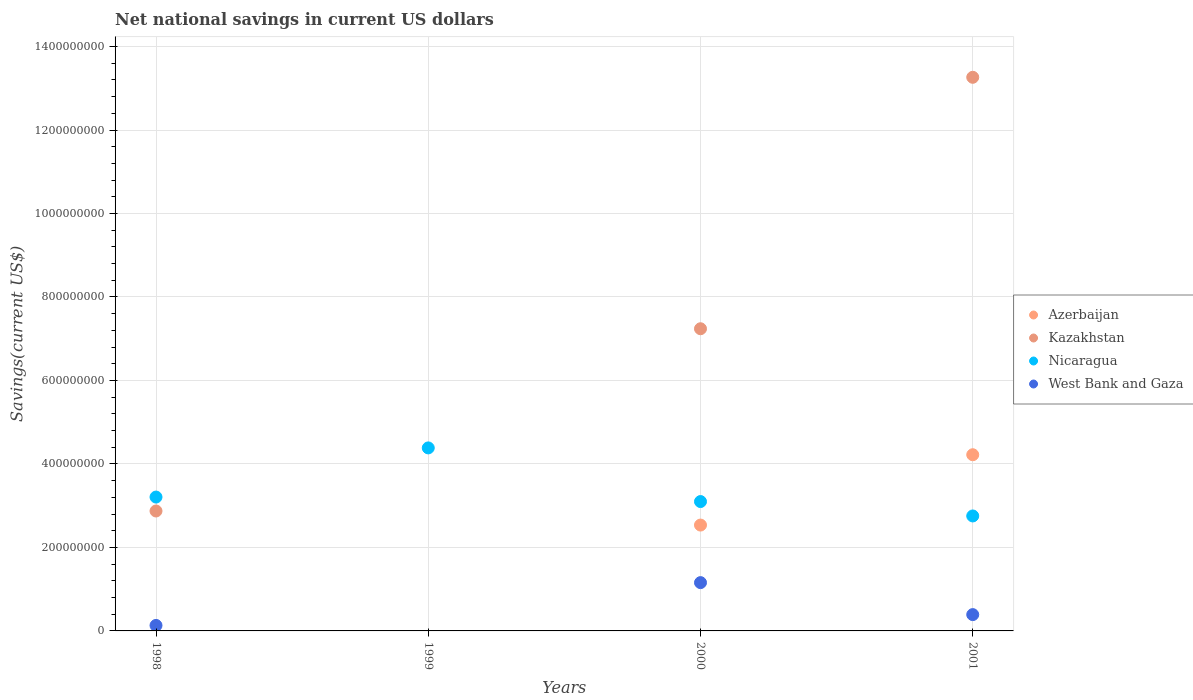How many different coloured dotlines are there?
Your response must be concise. 4. Is the number of dotlines equal to the number of legend labels?
Offer a very short reply. No. What is the net national savings in Nicaragua in 1998?
Give a very brief answer. 3.21e+08. Across all years, what is the maximum net national savings in Nicaragua?
Give a very brief answer. 4.38e+08. Across all years, what is the minimum net national savings in Azerbaijan?
Your response must be concise. 0. What is the total net national savings in Kazakhstan in the graph?
Ensure brevity in your answer.  2.34e+09. What is the difference between the net national savings in Nicaragua in 1998 and that in 2000?
Your answer should be very brief. 1.08e+07. What is the difference between the net national savings in Kazakhstan in 1998 and the net national savings in Nicaragua in 2001?
Ensure brevity in your answer.  1.19e+07. What is the average net national savings in Kazakhstan per year?
Your answer should be compact. 5.84e+08. In the year 2000, what is the difference between the net national savings in Kazakhstan and net national savings in West Bank and Gaza?
Offer a very short reply. 6.08e+08. What is the ratio of the net national savings in Nicaragua in 1999 to that in 2001?
Make the answer very short. 1.59. Is the difference between the net national savings in Kazakhstan in 1998 and 2001 greater than the difference between the net national savings in West Bank and Gaza in 1998 and 2001?
Offer a very short reply. No. What is the difference between the highest and the second highest net national savings in West Bank and Gaza?
Provide a short and direct response. 7.66e+07. What is the difference between the highest and the lowest net national savings in Azerbaijan?
Give a very brief answer. 4.22e+08. In how many years, is the net national savings in Kazakhstan greater than the average net national savings in Kazakhstan taken over all years?
Your answer should be compact. 2. Is the sum of the net national savings in Kazakhstan in 1998 and 2000 greater than the maximum net national savings in Nicaragua across all years?
Ensure brevity in your answer.  Yes. Does the net national savings in Kazakhstan monotonically increase over the years?
Your answer should be very brief. No. Is the net national savings in Azerbaijan strictly less than the net national savings in Kazakhstan over the years?
Your response must be concise. No. How many dotlines are there?
Your answer should be compact. 4. How many years are there in the graph?
Your response must be concise. 4. Does the graph contain any zero values?
Your response must be concise. Yes. Does the graph contain grids?
Ensure brevity in your answer.  Yes. Where does the legend appear in the graph?
Provide a succinct answer. Center right. What is the title of the graph?
Keep it short and to the point. Net national savings in current US dollars. Does "Guyana" appear as one of the legend labels in the graph?
Give a very brief answer. No. What is the label or title of the Y-axis?
Offer a terse response. Savings(current US$). What is the Savings(current US$) of Azerbaijan in 1998?
Offer a terse response. 0. What is the Savings(current US$) in Kazakhstan in 1998?
Offer a very short reply. 2.87e+08. What is the Savings(current US$) in Nicaragua in 1998?
Provide a succinct answer. 3.21e+08. What is the Savings(current US$) in West Bank and Gaza in 1998?
Your answer should be compact. 1.32e+07. What is the Savings(current US$) of Azerbaijan in 1999?
Make the answer very short. 0. What is the Savings(current US$) of Kazakhstan in 1999?
Your answer should be compact. 0. What is the Savings(current US$) in Nicaragua in 1999?
Provide a succinct answer. 4.38e+08. What is the Savings(current US$) of Azerbaijan in 2000?
Keep it short and to the point. 2.54e+08. What is the Savings(current US$) in Kazakhstan in 2000?
Offer a very short reply. 7.24e+08. What is the Savings(current US$) in Nicaragua in 2000?
Ensure brevity in your answer.  3.10e+08. What is the Savings(current US$) of West Bank and Gaza in 2000?
Your response must be concise. 1.16e+08. What is the Savings(current US$) of Azerbaijan in 2001?
Ensure brevity in your answer.  4.22e+08. What is the Savings(current US$) in Kazakhstan in 2001?
Ensure brevity in your answer.  1.33e+09. What is the Savings(current US$) of Nicaragua in 2001?
Provide a short and direct response. 2.75e+08. What is the Savings(current US$) of West Bank and Gaza in 2001?
Make the answer very short. 3.91e+07. Across all years, what is the maximum Savings(current US$) of Azerbaijan?
Your response must be concise. 4.22e+08. Across all years, what is the maximum Savings(current US$) in Kazakhstan?
Give a very brief answer. 1.33e+09. Across all years, what is the maximum Savings(current US$) in Nicaragua?
Offer a terse response. 4.38e+08. Across all years, what is the maximum Savings(current US$) of West Bank and Gaza?
Keep it short and to the point. 1.16e+08. Across all years, what is the minimum Savings(current US$) of Azerbaijan?
Provide a succinct answer. 0. Across all years, what is the minimum Savings(current US$) in Kazakhstan?
Provide a short and direct response. 0. Across all years, what is the minimum Savings(current US$) of Nicaragua?
Offer a terse response. 2.75e+08. Across all years, what is the minimum Savings(current US$) of West Bank and Gaza?
Offer a terse response. 0. What is the total Savings(current US$) of Azerbaijan in the graph?
Your response must be concise. 6.76e+08. What is the total Savings(current US$) of Kazakhstan in the graph?
Offer a very short reply. 2.34e+09. What is the total Savings(current US$) in Nicaragua in the graph?
Your answer should be very brief. 1.34e+09. What is the total Savings(current US$) of West Bank and Gaza in the graph?
Provide a succinct answer. 1.68e+08. What is the difference between the Savings(current US$) of Nicaragua in 1998 and that in 1999?
Keep it short and to the point. -1.18e+08. What is the difference between the Savings(current US$) in Kazakhstan in 1998 and that in 2000?
Offer a very short reply. -4.37e+08. What is the difference between the Savings(current US$) in Nicaragua in 1998 and that in 2000?
Ensure brevity in your answer.  1.08e+07. What is the difference between the Savings(current US$) of West Bank and Gaza in 1998 and that in 2000?
Provide a short and direct response. -1.03e+08. What is the difference between the Savings(current US$) in Kazakhstan in 1998 and that in 2001?
Make the answer very short. -1.04e+09. What is the difference between the Savings(current US$) in Nicaragua in 1998 and that in 2001?
Give a very brief answer. 4.52e+07. What is the difference between the Savings(current US$) in West Bank and Gaza in 1998 and that in 2001?
Offer a very short reply. -2.59e+07. What is the difference between the Savings(current US$) in Nicaragua in 1999 and that in 2000?
Your answer should be very brief. 1.29e+08. What is the difference between the Savings(current US$) in Nicaragua in 1999 and that in 2001?
Your answer should be very brief. 1.63e+08. What is the difference between the Savings(current US$) of Azerbaijan in 2000 and that in 2001?
Your response must be concise. -1.68e+08. What is the difference between the Savings(current US$) of Kazakhstan in 2000 and that in 2001?
Your answer should be compact. -6.02e+08. What is the difference between the Savings(current US$) of Nicaragua in 2000 and that in 2001?
Provide a succinct answer. 3.45e+07. What is the difference between the Savings(current US$) in West Bank and Gaza in 2000 and that in 2001?
Offer a terse response. 7.66e+07. What is the difference between the Savings(current US$) of Kazakhstan in 1998 and the Savings(current US$) of Nicaragua in 1999?
Your answer should be compact. -1.51e+08. What is the difference between the Savings(current US$) in Kazakhstan in 1998 and the Savings(current US$) in Nicaragua in 2000?
Your answer should be very brief. -2.26e+07. What is the difference between the Savings(current US$) of Kazakhstan in 1998 and the Savings(current US$) of West Bank and Gaza in 2000?
Ensure brevity in your answer.  1.72e+08. What is the difference between the Savings(current US$) in Nicaragua in 1998 and the Savings(current US$) in West Bank and Gaza in 2000?
Your response must be concise. 2.05e+08. What is the difference between the Savings(current US$) in Kazakhstan in 1998 and the Savings(current US$) in Nicaragua in 2001?
Provide a short and direct response. 1.19e+07. What is the difference between the Savings(current US$) in Kazakhstan in 1998 and the Savings(current US$) in West Bank and Gaza in 2001?
Your answer should be very brief. 2.48e+08. What is the difference between the Savings(current US$) in Nicaragua in 1998 and the Savings(current US$) in West Bank and Gaza in 2001?
Make the answer very short. 2.82e+08. What is the difference between the Savings(current US$) in Nicaragua in 1999 and the Savings(current US$) in West Bank and Gaza in 2000?
Ensure brevity in your answer.  3.23e+08. What is the difference between the Savings(current US$) of Nicaragua in 1999 and the Savings(current US$) of West Bank and Gaza in 2001?
Provide a succinct answer. 3.99e+08. What is the difference between the Savings(current US$) in Azerbaijan in 2000 and the Savings(current US$) in Kazakhstan in 2001?
Your answer should be very brief. -1.07e+09. What is the difference between the Savings(current US$) in Azerbaijan in 2000 and the Savings(current US$) in Nicaragua in 2001?
Your answer should be very brief. -2.18e+07. What is the difference between the Savings(current US$) of Azerbaijan in 2000 and the Savings(current US$) of West Bank and Gaza in 2001?
Ensure brevity in your answer.  2.15e+08. What is the difference between the Savings(current US$) of Kazakhstan in 2000 and the Savings(current US$) of Nicaragua in 2001?
Provide a short and direct response. 4.48e+08. What is the difference between the Savings(current US$) in Kazakhstan in 2000 and the Savings(current US$) in West Bank and Gaza in 2001?
Your response must be concise. 6.85e+08. What is the difference between the Savings(current US$) in Nicaragua in 2000 and the Savings(current US$) in West Bank and Gaza in 2001?
Offer a terse response. 2.71e+08. What is the average Savings(current US$) of Azerbaijan per year?
Provide a short and direct response. 1.69e+08. What is the average Savings(current US$) in Kazakhstan per year?
Keep it short and to the point. 5.84e+08. What is the average Savings(current US$) in Nicaragua per year?
Keep it short and to the point. 3.36e+08. What is the average Savings(current US$) of West Bank and Gaza per year?
Provide a short and direct response. 4.20e+07. In the year 1998, what is the difference between the Savings(current US$) in Kazakhstan and Savings(current US$) in Nicaragua?
Your answer should be compact. -3.34e+07. In the year 1998, what is the difference between the Savings(current US$) in Kazakhstan and Savings(current US$) in West Bank and Gaza?
Make the answer very short. 2.74e+08. In the year 1998, what is the difference between the Savings(current US$) of Nicaragua and Savings(current US$) of West Bank and Gaza?
Give a very brief answer. 3.08e+08. In the year 2000, what is the difference between the Savings(current US$) in Azerbaijan and Savings(current US$) in Kazakhstan?
Provide a succinct answer. -4.70e+08. In the year 2000, what is the difference between the Savings(current US$) in Azerbaijan and Savings(current US$) in Nicaragua?
Offer a very short reply. -5.63e+07. In the year 2000, what is the difference between the Savings(current US$) in Azerbaijan and Savings(current US$) in West Bank and Gaza?
Your answer should be compact. 1.38e+08. In the year 2000, what is the difference between the Savings(current US$) of Kazakhstan and Savings(current US$) of Nicaragua?
Make the answer very short. 4.14e+08. In the year 2000, what is the difference between the Savings(current US$) of Kazakhstan and Savings(current US$) of West Bank and Gaza?
Give a very brief answer. 6.08e+08. In the year 2000, what is the difference between the Savings(current US$) of Nicaragua and Savings(current US$) of West Bank and Gaza?
Offer a terse response. 1.94e+08. In the year 2001, what is the difference between the Savings(current US$) of Azerbaijan and Savings(current US$) of Kazakhstan?
Offer a terse response. -9.04e+08. In the year 2001, what is the difference between the Savings(current US$) in Azerbaijan and Savings(current US$) in Nicaragua?
Make the answer very short. 1.47e+08. In the year 2001, what is the difference between the Savings(current US$) of Azerbaijan and Savings(current US$) of West Bank and Gaza?
Give a very brief answer. 3.83e+08. In the year 2001, what is the difference between the Savings(current US$) in Kazakhstan and Savings(current US$) in Nicaragua?
Your answer should be compact. 1.05e+09. In the year 2001, what is the difference between the Savings(current US$) in Kazakhstan and Savings(current US$) in West Bank and Gaza?
Offer a terse response. 1.29e+09. In the year 2001, what is the difference between the Savings(current US$) of Nicaragua and Savings(current US$) of West Bank and Gaza?
Your response must be concise. 2.36e+08. What is the ratio of the Savings(current US$) in Nicaragua in 1998 to that in 1999?
Give a very brief answer. 0.73. What is the ratio of the Savings(current US$) of Kazakhstan in 1998 to that in 2000?
Your response must be concise. 0.4. What is the ratio of the Savings(current US$) of Nicaragua in 1998 to that in 2000?
Provide a short and direct response. 1.03. What is the ratio of the Savings(current US$) in West Bank and Gaza in 1998 to that in 2000?
Provide a succinct answer. 0.11. What is the ratio of the Savings(current US$) in Kazakhstan in 1998 to that in 2001?
Keep it short and to the point. 0.22. What is the ratio of the Savings(current US$) in Nicaragua in 1998 to that in 2001?
Your answer should be compact. 1.16. What is the ratio of the Savings(current US$) of West Bank and Gaza in 1998 to that in 2001?
Your answer should be compact. 0.34. What is the ratio of the Savings(current US$) in Nicaragua in 1999 to that in 2000?
Keep it short and to the point. 1.41. What is the ratio of the Savings(current US$) of Nicaragua in 1999 to that in 2001?
Ensure brevity in your answer.  1.59. What is the ratio of the Savings(current US$) in Azerbaijan in 2000 to that in 2001?
Ensure brevity in your answer.  0.6. What is the ratio of the Savings(current US$) of Kazakhstan in 2000 to that in 2001?
Your answer should be compact. 0.55. What is the ratio of the Savings(current US$) in Nicaragua in 2000 to that in 2001?
Offer a very short reply. 1.13. What is the ratio of the Savings(current US$) in West Bank and Gaza in 2000 to that in 2001?
Keep it short and to the point. 2.96. What is the difference between the highest and the second highest Savings(current US$) of Kazakhstan?
Your response must be concise. 6.02e+08. What is the difference between the highest and the second highest Savings(current US$) of Nicaragua?
Make the answer very short. 1.18e+08. What is the difference between the highest and the second highest Savings(current US$) of West Bank and Gaza?
Provide a succinct answer. 7.66e+07. What is the difference between the highest and the lowest Savings(current US$) of Azerbaijan?
Offer a very short reply. 4.22e+08. What is the difference between the highest and the lowest Savings(current US$) of Kazakhstan?
Provide a short and direct response. 1.33e+09. What is the difference between the highest and the lowest Savings(current US$) in Nicaragua?
Offer a very short reply. 1.63e+08. What is the difference between the highest and the lowest Savings(current US$) in West Bank and Gaza?
Make the answer very short. 1.16e+08. 